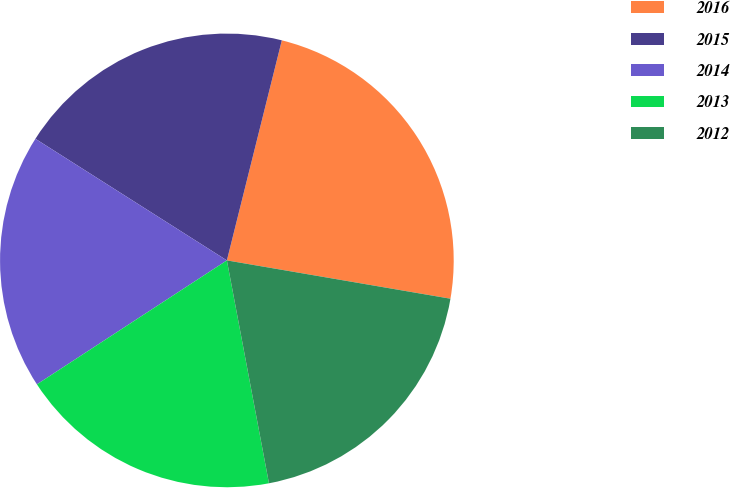Convert chart to OTSL. <chart><loc_0><loc_0><loc_500><loc_500><pie_chart><fcel>2016<fcel>2015<fcel>2014<fcel>2013<fcel>2012<nl><fcel>23.81%<fcel>19.89%<fcel>18.21%<fcel>18.77%<fcel>19.33%<nl></chart> 